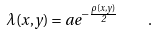Convert formula to latex. <formula><loc_0><loc_0><loc_500><loc_500>\lambda ( x , y ) = a e ^ { - \frac { \rho ( x , y ) } { 2 } } \, \quad .</formula> 